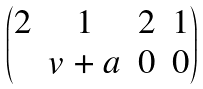Convert formula to latex. <formula><loc_0><loc_0><loc_500><loc_500>\begin{pmatrix} 2 & 1 & 2 & 1 \\ & v + a & 0 & 0 \end{pmatrix}</formula> 